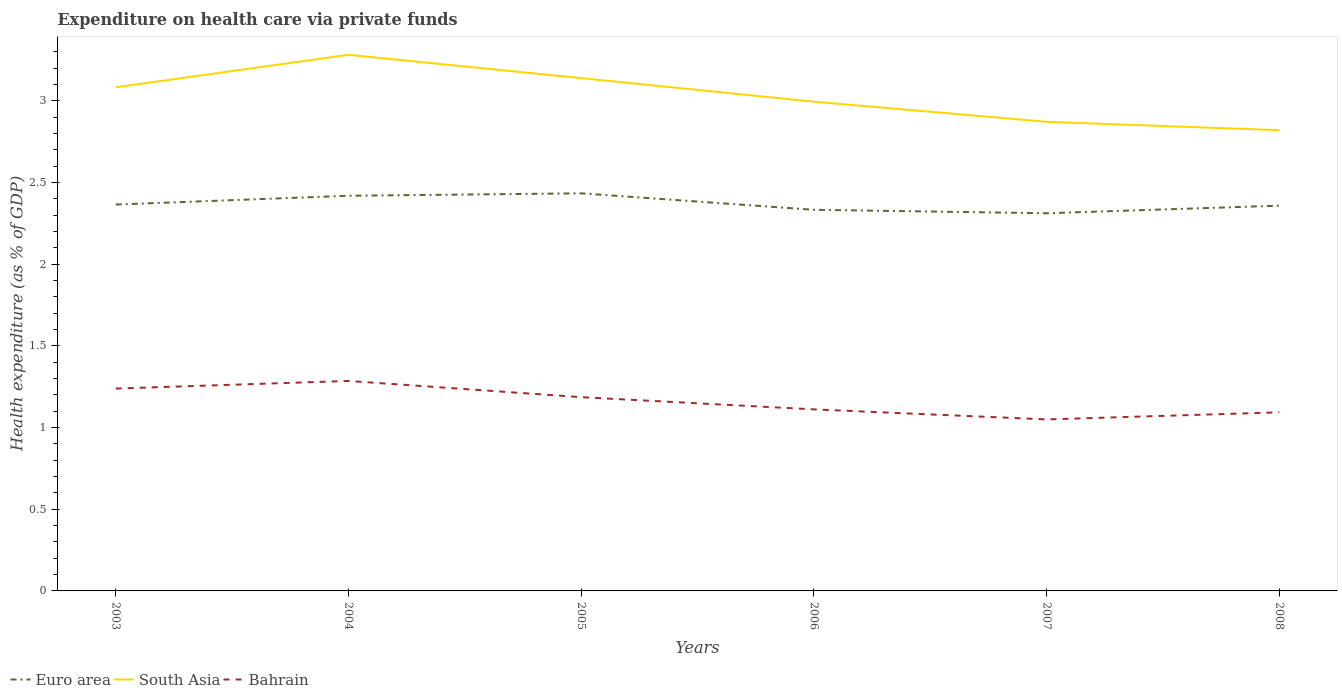Does the line corresponding to South Asia intersect with the line corresponding to Euro area?
Offer a terse response. No. Across all years, what is the maximum expenditure made on health care in South Asia?
Keep it short and to the point. 2.82. In which year was the expenditure made on health care in South Asia maximum?
Ensure brevity in your answer.  2008. What is the total expenditure made on health care in Bahrain in the graph?
Give a very brief answer. 0.24. What is the difference between the highest and the second highest expenditure made on health care in Bahrain?
Ensure brevity in your answer.  0.24. Is the expenditure made on health care in Euro area strictly greater than the expenditure made on health care in South Asia over the years?
Make the answer very short. Yes. How many years are there in the graph?
Keep it short and to the point. 6. What is the difference between two consecutive major ticks on the Y-axis?
Provide a short and direct response. 0.5. Are the values on the major ticks of Y-axis written in scientific E-notation?
Provide a succinct answer. No. Does the graph contain any zero values?
Give a very brief answer. No. How many legend labels are there?
Your response must be concise. 3. How are the legend labels stacked?
Ensure brevity in your answer.  Horizontal. What is the title of the graph?
Your answer should be very brief. Expenditure on health care via private funds. Does "Barbados" appear as one of the legend labels in the graph?
Offer a terse response. No. What is the label or title of the Y-axis?
Your answer should be very brief. Health expenditure (as % of GDP). What is the Health expenditure (as % of GDP) of Euro area in 2003?
Offer a terse response. 2.36. What is the Health expenditure (as % of GDP) in South Asia in 2003?
Offer a terse response. 3.08. What is the Health expenditure (as % of GDP) in Bahrain in 2003?
Your answer should be very brief. 1.24. What is the Health expenditure (as % of GDP) of Euro area in 2004?
Provide a succinct answer. 2.42. What is the Health expenditure (as % of GDP) in South Asia in 2004?
Offer a very short reply. 3.28. What is the Health expenditure (as % of GDP) of Bahrain in 2004?
Ensure brevity in your answer.  1.29. What is the Health expenditure (as % of GDP) in Euro area in 2005?
Keep it short and to the point. 2.43. What is the Health expenditure (as % of GDP) in South Asia in 2005?
Ensure brevity in your answer.  3.14. What is the Health expenditure (as % of GDP) in Bahrain in 2005?
Ensure brevity in your answer.  1.19. What is the Health expenditure (as % of GDP) in Euro area in 2006?
Your answer should be very brief. 2.33. What is the Health expenditure (as % of GDP) of South Asia in 2006?
Your answer should be compact. 2.99. What is the Health expenditure (as % of GDP) of Bahrain in 2006?
Your answer should be compact. 1.11. What is the Health expenditure (as % of GDP) in Euro area in 2007?
Keep it short and to the point. 2.31. What is the Health expenditure (as % of GDP) of South Asia in 2007?
Your response must be concise. 2.87. What is the Health expenditure (as % of GDP) of Bahrain in 2007?
Your response must be concise. 1.05. What is the Health expenditure (as % of GDP) in Euro area in 2008?
Give a very brief answer. 2.36. What is the Health expenditure (as % of GDP) of South Asia in 2008?
Offer a very short reply. 2.82. What is the Health expenditure (as % of GDP) in Bahrain in 2008?
Offer a terse response. 1.09. Across all years, what is the maximum Health expenditure (as % of GDP) in Euro area?
Give a very brief answer. 2.43. Across all years, what is the maximum Health expenditure (as % of GDP) in South Asia?
Your response must be concise. 3.28. Across all years, what is the maximum Health expenditure (as % of GDP) in Bahrain?
Your answer should be very brief. 1.29. Across all years, what is the minimum Health expenditure (as % of GDP) in Euro area?
Offer a very short reply. 2.31. Across all years, what is the minimum Health expenditure (as % of GDP) in South Asia?
Your answer should be very brief. 2.82. Across all years, what is the minimum Health expenditure (as % of GDP) of Bahrain?
Keep it short and to the point. 1.05. What is the total Health expenditure (as % of GDP) in Euro area in the graph?
Provide a succinct answer. 14.22. What is the total Health expenditure (as % of GDP) of South Asia in the graph?
Provide a succinct answer. 18.19. What is the total Health expenditure (as % of GDP) in Bahrain in the graph?
Offer a very short reply. 6.96. What is the difference between the Health expenditure (as % of GDP) of Euro area in 2003 and that in 2004?
Keep it short and to the point. -0.05. What is the difference between the Health expenditure (as % of GDP) of South Asia in 2003 and that in 2004?
Keep it short and to the point. -0.2. What is the difference between the Health expenditure (as % of GDP) of Bahrain in 2003 and that in 2004?
Make the answer very short. -0.05. What is the difference between the Health expenditure (as % of GDP) of Euro area in 2003 and that in 2005?
Offer a terse response. -0.07. What is the difference between the Health expenditure (as % of GDP) in South Asia in 2003 and that in 2005?
Your response must be concise. -0.06. What is the difference between the Health expenditure (as % of GDP) of Bahrain in 2003 and that in 2005?
Provide a short and direct response. 0.05. What is the difference between the Health expenditure (as % of GDP) in Euro area in 2003 and that in 2006?
Keep it short and to the point. 0.03. What is the difference between the Health expenditure (as % of GDP) in South Asia in 2003 and that in 2006?
Ensure brevity in your answer.  0.09. What is the difference between the Health expenditure (as % of GDP) in Bahrain in 2003 and that in 2006?
Give a very brief answer. 0.13. What is the difference between the Health expenditure (as % of GDP) of Euro area in 2003 and that in 2007?
Provide a short and direct response. 0.05. What is the difference between the Health expenditure (as % of GDP) of South Asia in 2003 and that in 2007?
Ensure brevity in your answer.  0.21. What is the difference between the Health expenditure (as % of GDP) of Bahrain in 2003 and that in 2007?
Your answer should be compact. 0.19. What is the difference between the Health expenditure (as % of GDP) in Euro area in 2003 and that in 2008?
Provide a short and direct response. 0.01. What is the difference between the Health expenditure (as % of GDP) in South Asia in 2003 and that in 2008?
Give a very brief answer. 0.26. What is the difference between the Health expenditure (as % of GDP) of Bahrain in 2003 and that in 2008?
Your response must be concise. 0.15. What is the difference between the Health expenditure (as % of GDP) of Euro area in 2004 and that in 2005?
Ensure brevity in your answer.  -0.01. What is the difference between the Health expenditure (as % of GDP) in South Asia in 2004 and that in 2005?
Your answer should be very brief. 0.14. What is the difference between the Health expenditure (as % of GDP) of Bahrain in 2004 and that in 2005?
Give a very brief answer. 0.1. What is the difference between the Health expenditure (as % of GDP) in Euro area in 2004 and that in 2006?
Give a very brief answer. 0.09. What is the difference between the Health expenditure (as % of GDP) in South Asia in 2004 and that in 2006?
Give a very brief answer. 0.29. What is the difference between the Health expenditure (as % of GDP) of Bahrain in 2004 and that in 2006?
Keep it short and to the point. 0.17. What is the difference between the Health expenditure (as % of GDP) in Euro area in 2004 and that in 2007?
Keep it short and to the point. 0.11. What is the difference between the Health expenditure (as % of GDP) of South Asia in 2004 and that in 2007?
Your answer should be compact. 0.41. What is the difference between the Health expenditure (as % of GDP) in Bahrain in 2004 and that in 2007?
Ensure brevity in your answer.  0.24. What is the difference between the Health expenditure (as % of GDP) in Euro area in 2004 and that in 2008?
Provide a succinct answer. 0.06. What is the difference between the Health expenditure (as % of GDP) of South Asia in 2004 and that in 2008?
Provide a short and direct response. 0.46. What is the difference between the Health expenditure (as % of GDP) of Bahrain in 2004 and that in 2008?
Your answer should be compact. 0.19. What is the difference between the Health expenditure (as % of GDP) of Euro area in 2005 and that in 2006?
Provide a succinct answer. 0.1. What is the difference between the Health expenditure (as % of GDP) of South Asia in 2005 and that in 2006?
Make the answer very short. 0.14. What is the difference between the Health expenditure (as % of GDP) of Bahrain in 2005 and that in 2006?
Your answer should be very brief. 0.07. What is the difference between the Health expenditure (as % of GDP) in Euro area in 2005 and that in 2007?
Provide a succinct answer. 0.12. What is the difference between the Health expenditure (as % of GDP) in South Asia in 2005 and that in 2007?
Make the answer very short. 0.27. What is the difference between the Health expenditure (as % of GDP) of Bahrain in 2005 and that in 2007?
Offer a terse response. 0.14. What is the difference between the Health expenditure (as % of GDP) of Euro area in 2005 and that in 2008?
Give a very brief answer. 0.08. What is the difference between the Health expenditure (as % of GDP) of South Asia in 2005 and that in 2008?
Offer a terse response. 0.32. What is the difference between the Health expenditure (as % of GDP) of Bahrain in 2005 and that in 2008?
Ensure brevity in your answer.  0.09. What is the difference between the Health expenditure (as % of GDP) of Euro area in 2006 and that in 2007?
Offer a very short reply. 0.02. What is the difference between the Health expenditure (as % of GDP) in South Asia in 2006 and that in 2007?
Ensure brevity in your answer.  0.12. What is the difference between the Health expenditure (as % of GDP) in Bahrain in 2006 and that in 2007?
Your response must be concise. 0.06. What is the difference between the Health expenditure (as % of GDP) in Euro area in 2006 and that in 2008?
Your answer should be very brief. -0.03. What is the difference between the Health expenditure (as % of GDP) in South Asia in 2006 and that in 2008?
Your answer should be compact. 0.17. What is the difference between the Health expenditure (as % of GDP) of Bahrain in 2006 and that in 2008?
Offer a terse response. 0.02. What is the difference between the Health expenditure (as % of GDP) in Euro area in 2007 and that in 2008?
Your response must be concise. -0.05. What is the difference between the Health expenditure (as % of GDP) in South Asia in 2007 and that in 2008?
Your answer should be compact. 0.05. What is the difference between the Health expenditure (as % of GDP) of Bahrain in 2007 and that in 2008?
Your answer should be very brief. -0.04. What is the difference between the Health expenditure (as % of GDP) in Euro area in 2003 and the Health expenditure (as % of GDP) in South Asia in 2004?
Keep it short and to the point. -0.92. What is the difference between the Health expenditure (as % of GDP) of Euro area in 2003 and the Health expenditure (as % of GDP) of Bahrain in 2004?
Offer a very short reply. 1.08. What is the difference between the Health expenditure (as % of GDP) in South Asia in 2003 and the Health expenditure (as % of GDP) in Bahrain in 2004?
Provide a short and direct response. 1.8. What is the difference between the Health expenditure (as % of GDP) of Euro area in 2003 and the Health expenditure (as % of GDP) of South Asia in 2005?
Offer a terse response. -0.77. What is the difference between the Health expenditure (as % of GDP) in Euro area in 2003 and the Health expenditure (as % of GDP) in Bahrain in 2005?
Your answer should be compact. 1.18. What is the difference between the Health expenditure (as % of GDP) of South Asia in 2003 and the Health expenditure (as % of GDP) of Bahrain in 2005?
Your answer should be very brief. 1.9. What is the difference between the Health expenditure (as % of GDP) in Euro area in 2003 and the Health expenditure (as % of GDP) in South Asia in 2006?
Offer a very short reply. -0.63. What is the difference between the Health expenditure (as % of GDP) in Euro area in 2003 and the Health expenditure (as % of GDP) in Bahrain in 2006?
Give a very brief answer. 1.25. What is the difference between the Health expenditure (as % of GDP) of South Asia in 2003 and the Health expenditure (as % of GDP) of Bahrain in 2006?
Your answer should be very brief. 1.97. What is the difference between the Health expenditure (as % of GDP) of Euro area in 2003 and the Health expenditure (as % of GDP) of South Asia in 2007?
Offer a very short reply. -0.51. What is the difference between the Health expenditure (as % of GDP) of Euro area in 2003 and the Health expenditure (as % of GDP) of Bahrain in 2007?
Provide a succinct answer. 1.32. What is the difference between the Health expenditure (as % of GDP) in South Asia in 2003 and the Health expenditure (as % of GDP) in Bahrain in 2007?
Your response must be concise. 2.03. What is the difference between the Health expenditure (as % of GDP) in Euro area in 2003 and the Health expenditure (as % of GDP) in South Asia in 2008?
Provide a short and direct response. -0.46. What is the difference between the Health expenditure (as % of GDP) in Euro area in 2003 and the Health expenditure (as % of GDP) in Bahrain in 2008?
Make the answer very short. 1.27. What is the difference between the Health expenditure (as % of GDP) in South Asia in 2003 and the Health expenditure (as % of GDP) in Bahrain in 2008?
Keep it short and to the point. 1.99. What is the difference between the Health expenditure (as % of GDP) in Euro area in 2004 and the Health expenditure (as % of GDP) in South Asia in 2005?
Your answer should be very brief. -0.72. What is the difference between the Health expenditure (as % of GDP) of Euro area in 2004 and the Health expenditure (as % of GDP) of Bahrain in 2005?
Keep it short and to the point. 1.23. What is the difference between the Health expenditure (as % of GDP) of South Asia in 2004 and the Health expenditure (as % of GDP) of Bahrain in 2005?
Your answer should be very brief. 2.1. What is the difference between the Health expenditure (as % of GDP) in Euro area in 2004 and the Health expenditure (as % of GDP) in South Asia in 2006?
Your response must be concise. -0.58. What is the difference between the Health expenditure (as % of GDP) in Euro area in 2004 and the Health expenditure (as % of GDP) in Bahrain in 2006?
Provide a succinct answer. 1.31. What is the difference between the Health expenditure (as % of GDP) in South Asia in 2004 and the Health expenditure (as % of GDP) in Bahrain in 2006?
Ensure brevity in your answer.  2.17. What is the difference between the Health expenditure (as % of GDP) of Euro area in 2004 and the Health expenditure (as % of GDP) of South Asia in 2007?
Provide a short and direct response. -0.45. What is the difference between the Health expenditure (as % of GDP) of Euro area in 2004 and the Health expenditure (as % of GDP) of Bahrain in 2007?
Provide a short and direct response. 1.37. What is the difference between the Health expenditure (as % of GDP) in South Asia in 2004 and the Health expenditure (as % of GDP) in Bahrain in 2007?
Provide a succinct answer. 2.23. What is the difference between the Health expenditure (as % of GDP) of Euro area in 2004 and the Health expenditure (as % of GDP) of South Asia in 2008?
Offer a terse response. -0.4. What is the difference between the Health expenditure (as % of GDP) of Euro area in 2004 and the Health expenditure (as % of GDP) of Bahrain in 2008?
Provide a short and direct response. 1.33. What is the difference between the Health expenditure (as % of GDP) of South Asia in 2004 and the Health expenditure (as % of GDP) of Bahrain in 2008?
Offer a terse response. 2.19. What is the difference between the Health expenditure (as % of GDP) in Euro area in 2005 and the Health expenditure (as % of GDP) in South Asia in 2006?
Keep it short and to the point. -0.56. What is the difference between the Health expenditure (as % of GDP) in Euro area in 2005 and the Health expenditure (as % of GDP) in Bahrain in 2006?
Your response must be concise. 1.32. What is the difference between the Health expenditure (as % of GDP) of South Asia in 2005 and the Health expenditure (as % of GDP) of Bahrain in 2006?
Offer a terse response. 2.03. What is the difference between the Health expenditure (as % of GDP) of Euro area in 2005 and the Health expenditure (as % of GDP) of South Asia in 2007?
Your answer should be compact. -0.44. What is the difference between the Health expenditure (as % of GDP) in Euro area in 2005 and the Health expenditure (as % of GDP) in Bahrain in 2007?
Your answer should be very brief. 1.38. What is the difference between the Health expenditure (as % of GDP) in South Asia in 2005 and the Health expenditure (as % of GDP) in Bahrain in 2007?
Ensure brevity in your answer.  2.09. What is the difference between the Health expenditure (as % of GDP) in Euro area in 2005 and the Health expenditure (as % of GDP) in South Asia in 2008?
Keep it short and to the point. -0.39. What is the difference between the Health expenditure (as % of GDP) in Euro area in 2005 and the Health expenditure (as % of GDP) in Bahrain in 2008?
Your response must be concise. 1.34. What is the difference between the Health expenditure (as % of GDP) of South Asia in 2005 and the Health expenditure (as % of GDP) of Bahrain in 2008?
Ensure brevity in your answer.  2.05. What is the difference between the Health expenditure (as % of GDP) of Euro area in 2006 and the Health expenditure (as % of GDP) of South Asia in 2007?
Make the answer very short. -0.54. What is the difference between the Health expenditure (as % of GDP) of Euro area in 2006 and the Health expenditure (as % of GDP) of Bahrain in 2007?
Your response must be concise. 1.28. What is the difference between the Health expenditure (as % of GDP) of South Asia in 2006 and the Health expenditure (as % of GDP) of Bahrain in 2007?
Offer a very short reply. 1.94. What is the difference between the Health expenditure (as % of GDP) of Euro area in 2006 and the Health expenditure (as % of GDP) of South Asia in 2008?
Provide a short and direct response. -0.49. What is the difference between the Health expenditure (as % of GDP) in Euro area in 2006 and the Health expenditure (as % of GDP) in Bahrain in 2008?
Make the answer very short. 1.24. What is the difference between the Health expenditure (as % of GDP) in South Asia in 2006 and the Health expenditure (as % of GDP) in Bahrain in 2008?
Provide a succinct answer. 1.9. What is the difference between the Health expenditure (as % of GDP) of Euro area in 2007 and the Health expenditure (as % of GDP) of South Asia in 2008?
Provide a succinct answer. -0.51. What is the difference between the Health expenditure (as % of GDP) in Euro area in 2007 and the Health expenditure (as % of GDP) in Bahrain in 2008?
Offer a very short reply. 1.22. What is the difference between the Health expenditure (as % of GDP) in South Asia in 2007 and the Health expenditure (as % of GDP) in Bahrain in 2008?
Ensure brevity in your answer.  1.78. What is the average Health expenditure (as % of GDP) of Euro area per year?
Your response must be concise. 2.37. What is the average Health expenditure (as % of GDP) of South Asia per year?
Your response must be concise. 3.03. What is the average Health expenditure (as % of GDP) of Bahrain per year?
Provide a short and direct response. 1.16. In the year 2003, what is the difference between the Health expenditure (as % of GDP) of Euro area and Health expenditure (as % of GDP) of South Asia?
Make the answer very short. -0.72. In the year 2003, what is the difference between the Health expenditure (as % of GDP) of Euro area and Health expenditure (as % of GDP) of Bahrain?
Make the answer very short. 1.13. In the year 2003, what is the difference between the Health expenditure (as % of GDP) in South Asia and Health expenditure (as % of GDP) in Bahrain?
Your answer should be very brief. 1.84. In the year 2004, what is the difference between the Health expenditure (as % of GDP) of Euro area and Health expenditure (as % of GDP) of South Asia?
Provide a succinct answer. -0.86. In the year 2004, what is the difference between the Health expenditure (as % of GDP) of Euro area and Health expenditure (as % of GDP) of Bahrain?
Offer a terse response. 1.13. In the year 2004, what is the difference between the Health expenditure (as % of GDP) of South Asia and Health expenditure (as % of GDP) of Bahrain?
Ensure brevity in your answer.  2. In the year 2005, what is the difference between the Health expenditure (as % of GDP) in Euro area and Health expenditure (as % of GDP) in South Asia?
Keep it short and to the point. -0.71. In the year 2005, what is the difference between the Health expenditure (as % of GDP) of Euro area and Health expenditure (as % of GDP) of Bahrain?
Offer a terse response. 1.25. In the year 2005, what is the difference between the Health expenditure (as % of GDP) in South Asia and Health expenditure (as % of GDP) in Bahrain?
Offer a terse response. 1.95. In the year 2006, what is the difference between the Health expenditure (as % of GDP) of Euro area and Health expenditure (as % of GDP) of South Asia?
Ensure brevity in your answer.  -0.66. In the year 2006, what is the difference between the Health expenditure (as % of GDP) in Euro area and Health expenditure (as % of GDP) in Bahrain?
Keep it short and to the point. 1.22. In the year 2006, what is the difference between the Health expenditure (as % of GDP) in South Asia and Health expenditure (as % of GDP) in Bahrain?
Provide a short and direct response. 1.88. In the year 2007, what is the difference between the Health expenditure (as % of GDP) in Euro area and Health expenditure (as % of GDP) in South Asia?
Offer a very short reply. -0.56. In the year 2007, what is the difference between the Health expenditure (as % of GDP) in Euro area and Health expenditure (as % of GDP) in Bahrain?
Make the answer very short. 1.26. In the year 2007, what is the difference between the Health expenditure (as % of GDP) in South Asia and Health expenditure (as % of GDP) in Bahrain?
Offer a terse response. 1.82. In the year 2008, what is the difference between the Health expenditure (as % of GDP) of Euro area and Health expenditure (as % of GDP) of South Asia?
Ensure brevity in your answer.  -0.46. In the year 2008, what is the difference between the Health expenditure (as % of GDP) of Euro area and Health expenditure (as % of GDP) of Bahrain?
Ensure brevity in your answer.  1.27. In the year 2008, what is the difference between the Health expenditure (as % of GDP) in South Asia and Health expenditure (as % of GDP) in Bahrain?
Ensure brevity in your answer.  1.73. What is the ratio of the Health expenditure (as % of GDP) of Euro area in 2003 to that in 2004?
Ensure brevity in your answer.  0.98. What is the ratio of the Health expenditure (as % of GDP) in South Asia in 2003 to that in 2004?
Your answer should be compact. 0.94. What is the ratio of the Health expenditure (as % of GDP) in Bahrain in 2003 to that in 2004?
Ensure brevity in your answer.  0.96. What is the ratio of the Health expenditure (as % of GDP) of Euro area in 2003 to that in 2005?
Offer a terse response. 0.97. What is the ratio of the Health expenditure (as % of GDP) in South Asia in 2003 to that in 2005?
Offer a terse response. 0.98. What is the ratio of the Health expenditure (as % of GDP) of Bahrain in 2003 to that in 2005?
Make the answer very short. 1.04. What is the ratio of the Health expenditure (as % of GDP) of Euro area in 2003 to that in 2006?
Your response must be concise. 1.01. What is the ratio of the Health expenditure (as % of GDP) of South Asia in 2003 to that in 2006?
Keep it short and to the point. 1.03. What is the ratio of the Health expenditure (as % of GDP) of Bahrain in 2003 to that in 2006?
Offer a very short reply. 1.11. What is the ratio of the Health expenditure (as % of GDP) in Euro area in 2003 to that in 2007?
Provide a short and direct response. 1.02. What is the ratio of the Health expenditure (as % of GDP) in South Asia in 2003 to that in 2007?
Provide a succinct answer. 1.07. What is the ratio of the Health expenditure (as % of GDP) in Bahrain in 2003 to that in 2007?
Your answer should be compact. 1.18. What is the ratio of the Health expenditure (as % of GDP) in Euro area in 2003 to that in 2008?
Keep it short and to the point. 1. What is the ratio of the Health expenditure (as % of GDP) of South Asia in 2003 to that in 2008?
Keep it short and to the point. 1.09. What is the ratio of the Health expenditure (as % of GDP) of Bahrain in 2003 to that in 2008?
Keep it short and to the point. 1.13. What is the ratio of the Health expenditure (as % of GDP) in South Asia in 2004 to that in 2005?
Ensure brevity in your answer.  1.05. What is the ratio of the Health expenditure (as % of GDP) of Bahrain in 2004 to that in 2005?
Give a very brief answer. 1.08. What is the ratio of the Health expenditure (as % of GDP) in Euro area in 2004 to that in 2006?
Provide a succinct answer. 1.04. What is the ratio of the Health expenditure (as % of GDP) in South Asia in 2004 to that in 2006?
Ensure brevity in your answer.  1.1. What is the ratio of the Health expenditure (as % of GDP) in Bahrain in 2004 to that in 2006?
Offer a terse response. 1.16. What is the ratio of the Health expenditure (as % of GDP) of Euro area in 2004 to that in 2007?
Your response must be concise. 1.05. What is the ratio of the Health expenditure (as % of GDP) of South Asia in 2004 to that in 2007?
Provide a succinct answer. 1.14. What is the ratio of the Health expenditure (as % of GDP) in Bahrain in 2004 to that in 2007?
Ensure brevity in your answer.  1.22. What is the ratio of the Health expenditure (as % of GDP) of Euro area in 2004 to that in 2008?
Your response must be concise. 1.03. What is the ratio of the Health expenditure (as % of GDP) in South Asia in 2004 to that in 2008?
Keep it short and to the point. 1.16. What is the ratio of the Health expenditure (as % of GDP) of Bahrain in 2004 to that in 2008?
Your answer should be very brief. 1.18. What is the ratio of the Health expenditure (as % of GDP) of Euro area in 2005 to that in 2006?
Provide a short and direct response. 1.04. What is the ratio of the Health expenditure (as % of GDP) in South Asia in 2005 to that in 2006?
Provide a short and direct response. 1.05. What is the ratio of the Health expenditure (as % of GDP) in Bahrain in 2005 to that in 2006?
Provide a succinct answer. 1.07. What is the ratio of the Health expenditure (as % of GDP) in Euro area in 2005 to that in 2007?
Provide a succinct answer. 1.05. What is the ratio of the Health expenditure (as % of GDP) in South Asia in 2005 to that in 2007?
Offer a very short reply. 1.09. What is the ratio of the Health expenditure (as % of GDP) in Bahrain in 2005 to that in 2007?
Make the answer very short. 1.13. What is the ratio of the Health expenditure (as % of GDP) of Euro area in 2005 to that in 2008?
Ensure brevity in your answer.  1.03. What is the ratio of the Health expenditure (as % of GDP) in South Asia in 2005 to that in 2008?
Provide a short and direct response. 1.11. What is the ratio of the Health expenditure (as % of GDP) of Bahrain in 2005 to that in 2008?
Your response must be concise. 1.08. What is the ratio of the Health expenditure (as % of GDP) in Euro area in 2006 to that in 2007?
Keep it short and to the point. 1.01. What is the ratio of the Health expenditure (as % of GDP) in South Asia in 2006 to that in 2007?
Your answer should be very brief. 1.04. What is the ratio of the Health expenditure (as % of GDP) of Bahrain in 2006 to that in 2007?
Your answer should be compact. 1.06. What is the ratio of the Health expenditure (as % of GDP) in Euro area in 2006 to that in 2008?
Keep it short and to the point. 0.99. What is the ratio of the Health expenditure (as % of GDP) of South Asia in 2006 to that in 2008?
Give a very brief answer. 1.06. What is the ratio of the Health expenditure (as % of GDP) in Bahrain in 2006 to that in 2008?
Your answer should be very brief. 1.02. What is the ratio of the Health expenditure (as % of GDP) in Euro area in 2007 to that in 2008?
Offer a terse response. 0.98. What is the ratio of the Health expenditure (as % of GDP) in South Asia in 2007 to that in 2008?
Provide a succinct answer. 1.02. What is the ratio of the Health expenditure (as % of GDP) in Bahrain in 2007 to that in 2008?
Your response must be concise. 0.96. What is the difference between the highest and the second highest Health expenditure (as % of GDP) of Euro area?
Ensure brevity in your answer.  0.01. What is the difference between the highest and the second highest Health expenditure (as % of GDP) of South Asia?
Your answer should be very brief. 0.14. What is the difference between the highest and the second highest Health expenditure (as % of GDP) in Bahrain?
Your answer should be compact. 0.05. What is the difference between the highest and the lowest Health expenditure (as % of GDP) in Euro area?
Ensure brevity in your answer.  0.12. What is the difference between the highest and the lowest Health expenditure (as % of GDP) in South Asia?
Make the answer very short. 0.46. What is the difference between the highest and the lowest Health expenditure (as % of GDP) in Bahrain?
Make the answer very short. 0.24. 